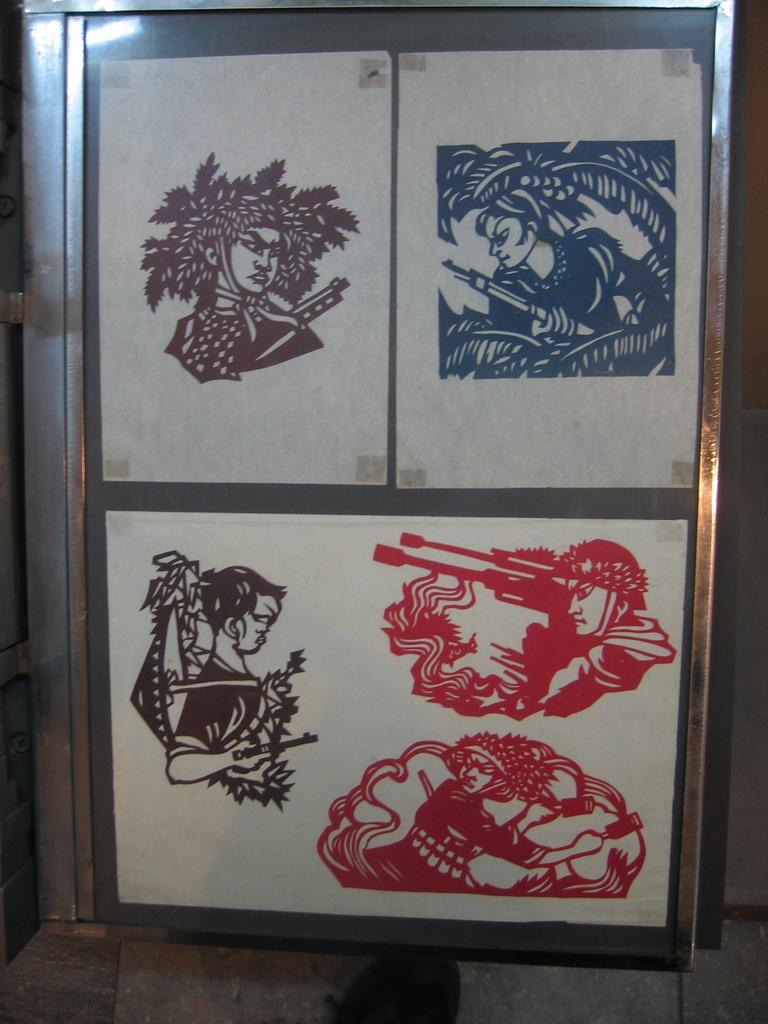What is the main subject of the image? There is a painting in the image. What does the painting depict? The painting depicts a few people. Where is the painting located in the image? The painting is on the door of a cupboard. What type of tramp can be seen jumping in the painting? There is no tramp present in the painting; it depicts a few people. What color is the sheet used to cover the people in the painting? There is no sheet covering the people in the painting; they are depicted as they are. 